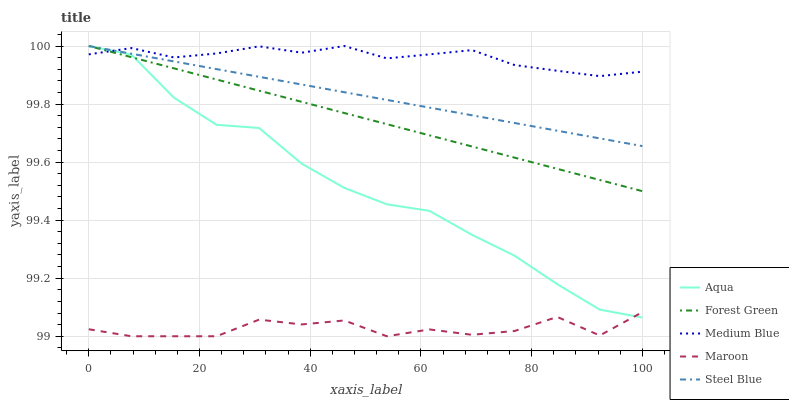Does Maroon have the minimum area under the curve?
Answer yes or no. Yes. Does Medium Blue have the maximum area under the curve?
Answer yes or no. Yes. Does Forest Green have the minimum area under the curve?
Answer yes or no. No. Does Forest Green have the maximum area under the curve?
Answer yes or no. No. Is Steel Blue the smoothest?
Answer yes or no. Yes. Is Maroon the roughest?
Answer yes or no. Yes. Is Forest Green the smoothest?
Answer yes or no. No. Is Forest Green the roughest?
Answer yes or no. No. Does Maroon have the lowest value?
Answer yes or no. Yes. Does Forest Green have the lowest value?
Answer yes or no. No. Does Steel Blue have the highest value?
Answer yes or no. Yes. Does Maroon have the highest value?
Answer yes or no. No. Is Maroon less than Forest Green?
Answer yes or no. Yes. Is Medium Blue greater than Maroon?
Answer yes or no. Yes. Does Maroon intersect Aqua?
Answer yes or no. Yes. Is Maroon less than Aqua?
Answer yes or no. No. Is Maroon greater than Aqua?
Answer yes or no. No. Does Maroon intersect Forest Green?
Answer yes or no. No. 